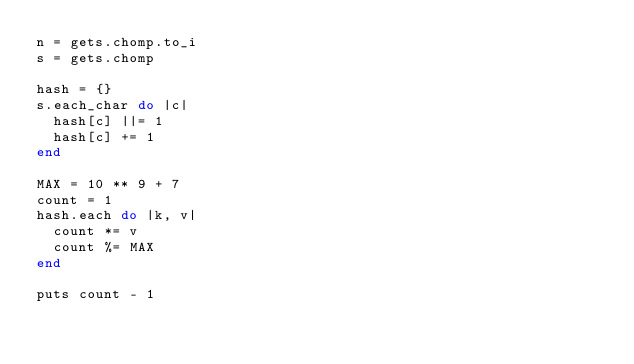Convert code to text. <code><loc_0><loc_0><loc_500><loc_500><_Ruby_>n = gets.chomp.to_i
s = gets.chomp

hash = {}
s.each_char do |c|
  hash[c] ||= 1
  hash[c] += 1
end

MAX = 10 ** 9 + 7
count = 1
hash.each do |k, v|
  count *= v
  count %= MAX
end

puts count - 1
</code> 